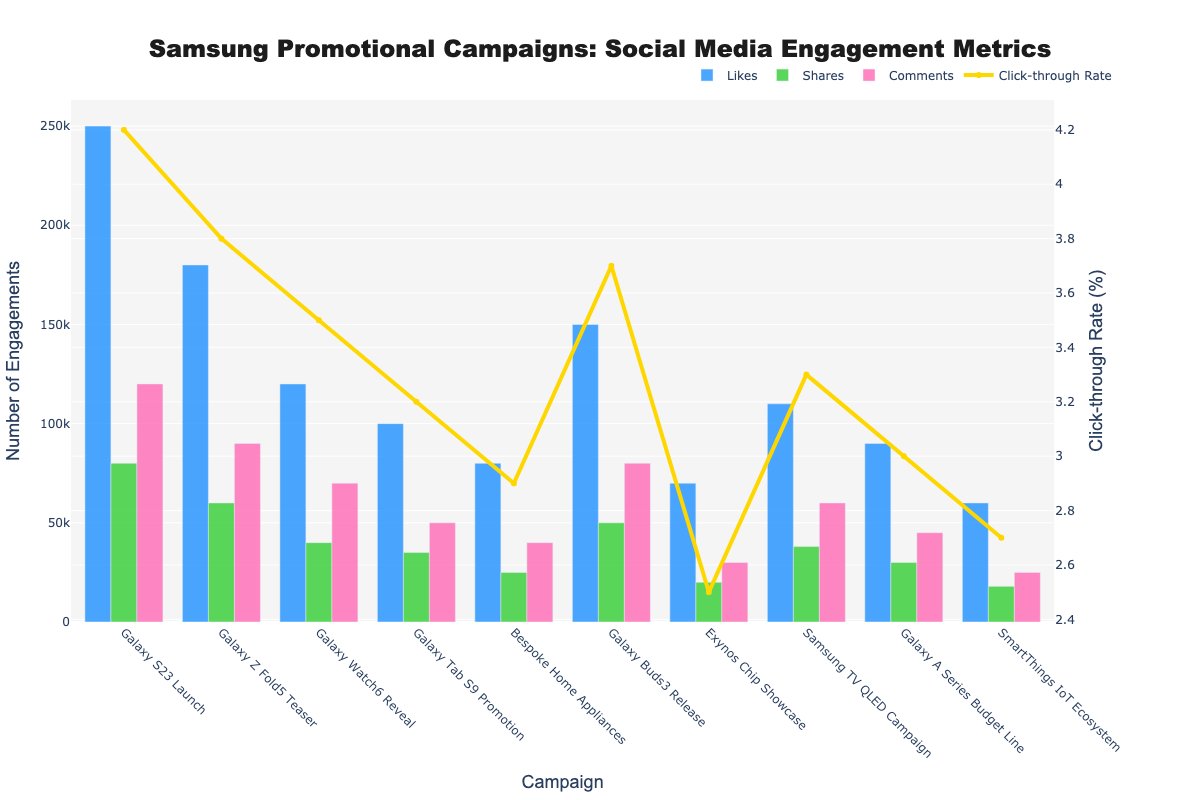What's the total number of Likes for all campaigns combined? To find the total number of Likes, sum the Likes from all the campaigns: 250,000 (S23) + 180,000 (Fold5) + 120,000 (Watch6) + 100,000 (Tab S9) + 80,000 (Bespoke) + 150,000 (Buds3) + 70,000 (Exynos) + 110,000 (TV QLED) + 90,000 (A Series) + 60,000 (SmartThings) = 1,210,000
Answer: 1,210,000 Which campaign had the highest number of Shares? The bar for Shares is the highest for the "Galaxy S23 Launch" campaign.
Answer: Galaxy S23 Launch What's the average Click-through Rate across all campaigns? To calculate the average Click-through Rate, sum the Click-through Rates and divide by the number of campaigns: (4.2 + 3.8 + 3.5 + 3.2 + 2.9 + 3.7 + 2.5 + 3.3 + 3.0 + 2.7) / 10 = 33.8 / 10 = 3.38
Answer: 3.38 Which campaign has the lowest number of Comments and what is the value? The "Exynos Chip Showcase" campaign has the lowest bar for Comments with 30,000 comments.
Answer: Exynos Chip Showcase, 30,000 Compare the number of Likes and Shares for the "Galaxy Watch6 Reveal" campaign. Which one is higher? For the "Galaxy Watch6 Reveal" campaign, the number of Likes is 120,000 and the number of Shares is 40,000. Since 120,000 > 40,000, Likes are higher.
Answer: Likes What is the difference between the Click-through Rate of the "Galaxy Buds3 Release" and "Galaxy Tab S9 Promotion"? The Click-through Rate of "Galaxy Buds3 Release" is 3.7, and "Galaxy Tab S9 Promotion" is 3.2. Subtracting 3.2 from 3.7, the difference is 0.5.
Answer: 0.5 Which campaign had a higher number of Likes: "Samsung TV QLED Campaign" or "Bespoke Home Appliances"? "Samsung TV QLED Campaign" had 110,000 Likes, whereas "Bespoke Home Appliances" had 80,000 Likes. Since 110,000 > 80,000, "Samsung TV QLED Campaign" had higher Likes.
Answer: Samsung TV QLED Campaign What is the total number of Comments for the three campaigns with the least Comments? The three campaigns with the least Comments are "SmartThings IoT Ecosystem" (25,000), "Exynos Chip Showcase" (30,000), and "Bespoke Home Appliances" (40,000). Total Comments = 25,000 + 30,000 + 40,000 = 95,000
Answer: 95,000 Compare the Click-through Rate of the "Galaxy A Series Budget Line" to the average Click-through Rate. Is it below or above average? The average Click-through Rate across all campaigns is 3.38. The Click-through Rate for "Galaxy A Series Budget Line" is 3.0. Since 3.0 < 3.38, it's below average.
Answer: Below average 